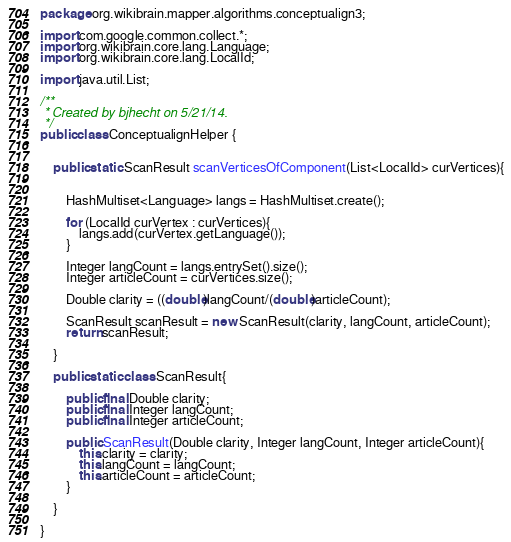Convert code to text. <code><loc_0><loc_0><loc_500><loc_500><_Java_>package org.wikibrain.mapper.algorithms.conceptualign3;

import com.google.common.collect.*;
import org.wikibrain.core.lang.Language;
import org.wikibrain.core.lang.LocalId;

import java.util.List;

/**
 * Created by bjhecht on 5/21/14.
 */
public class ConceptualignHelper {


    public static ScanResult scanVerticesOfComponent(List<LocalId> curVertices){


        HashMultiset<Language> langs = HashMultiset.create();

        for (LocalId curVertex : curVertices){
            langs.add(curVertex.getLanguage());
        }

        Integer langCount = langs.entrySet().size();
        Integer articleCount = curVertices.size();

        Double clarity = ((double)langCount/(double)articleCount);

        ScanResult scanResult = new ScanResult(clarity, langCount, articleCount);
        return scanResult;

    }

    public static class ScanResult{

        public final Double clarity;
        public final Integer langCount;
        public final Integer articleCount;

        public ScanResult(Double clarity, Integer langCount, Integer articleCount){
            this.clarity = clarity;
            this.langCount = langCount;
            this.articleCount = articleCount;
        }

    }

}
</code> 